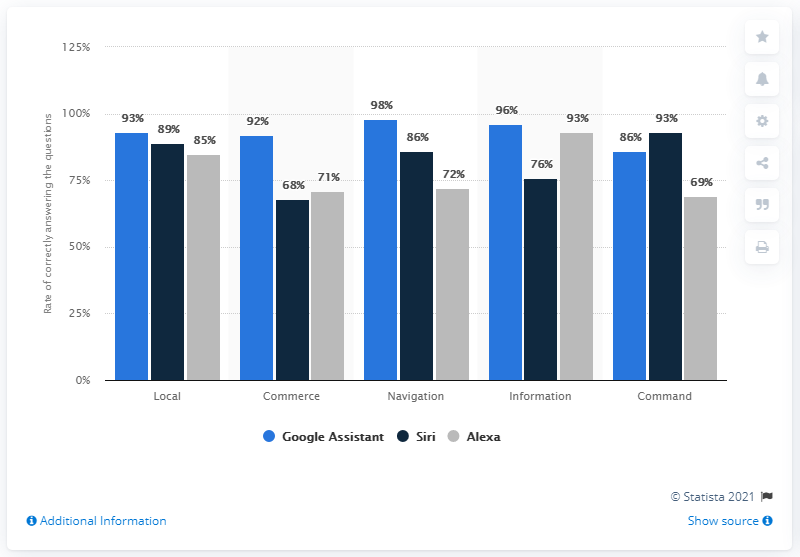Give some essential details in this illustration. Ninety-eight percent of navigation-related questions were answered correctly by Google Assistant. The Google Assistant was the most effective at answering questions correctly among the selected digital assistants. The average percentage of Siri is 82.4%. In my opinion, Siri was the most reliable Apple assistant when it came to executing commands accurately. The 98% rating for "Blue Bar" in the Navigation category on Google Assistant indicates a high level of quality and performance for this category. 